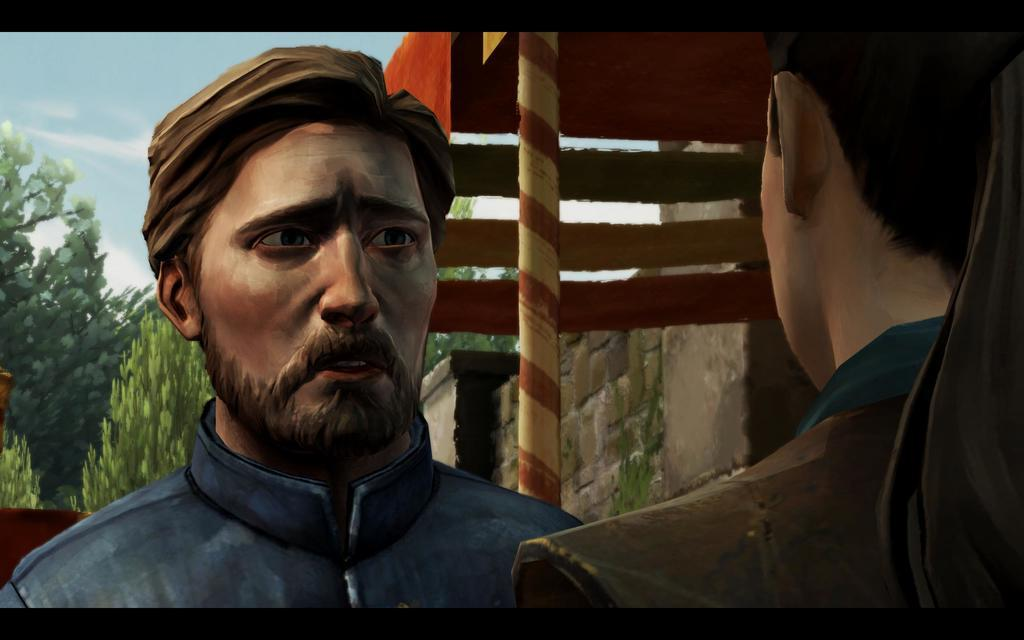What is located on the right side of the image? There is a person on the right side of the image. What is located on the left side of the image? There is a man on the left side of the image. What can be seen in the background of the image? There is a pole, trees, and walls in the background of the image. What type of watch is the person wearing in the image? There is no watch visible on the person in the image. What color is the paint on the walls in the image? There is no paint visible on the walls in the image; the walls are not described as painted. 